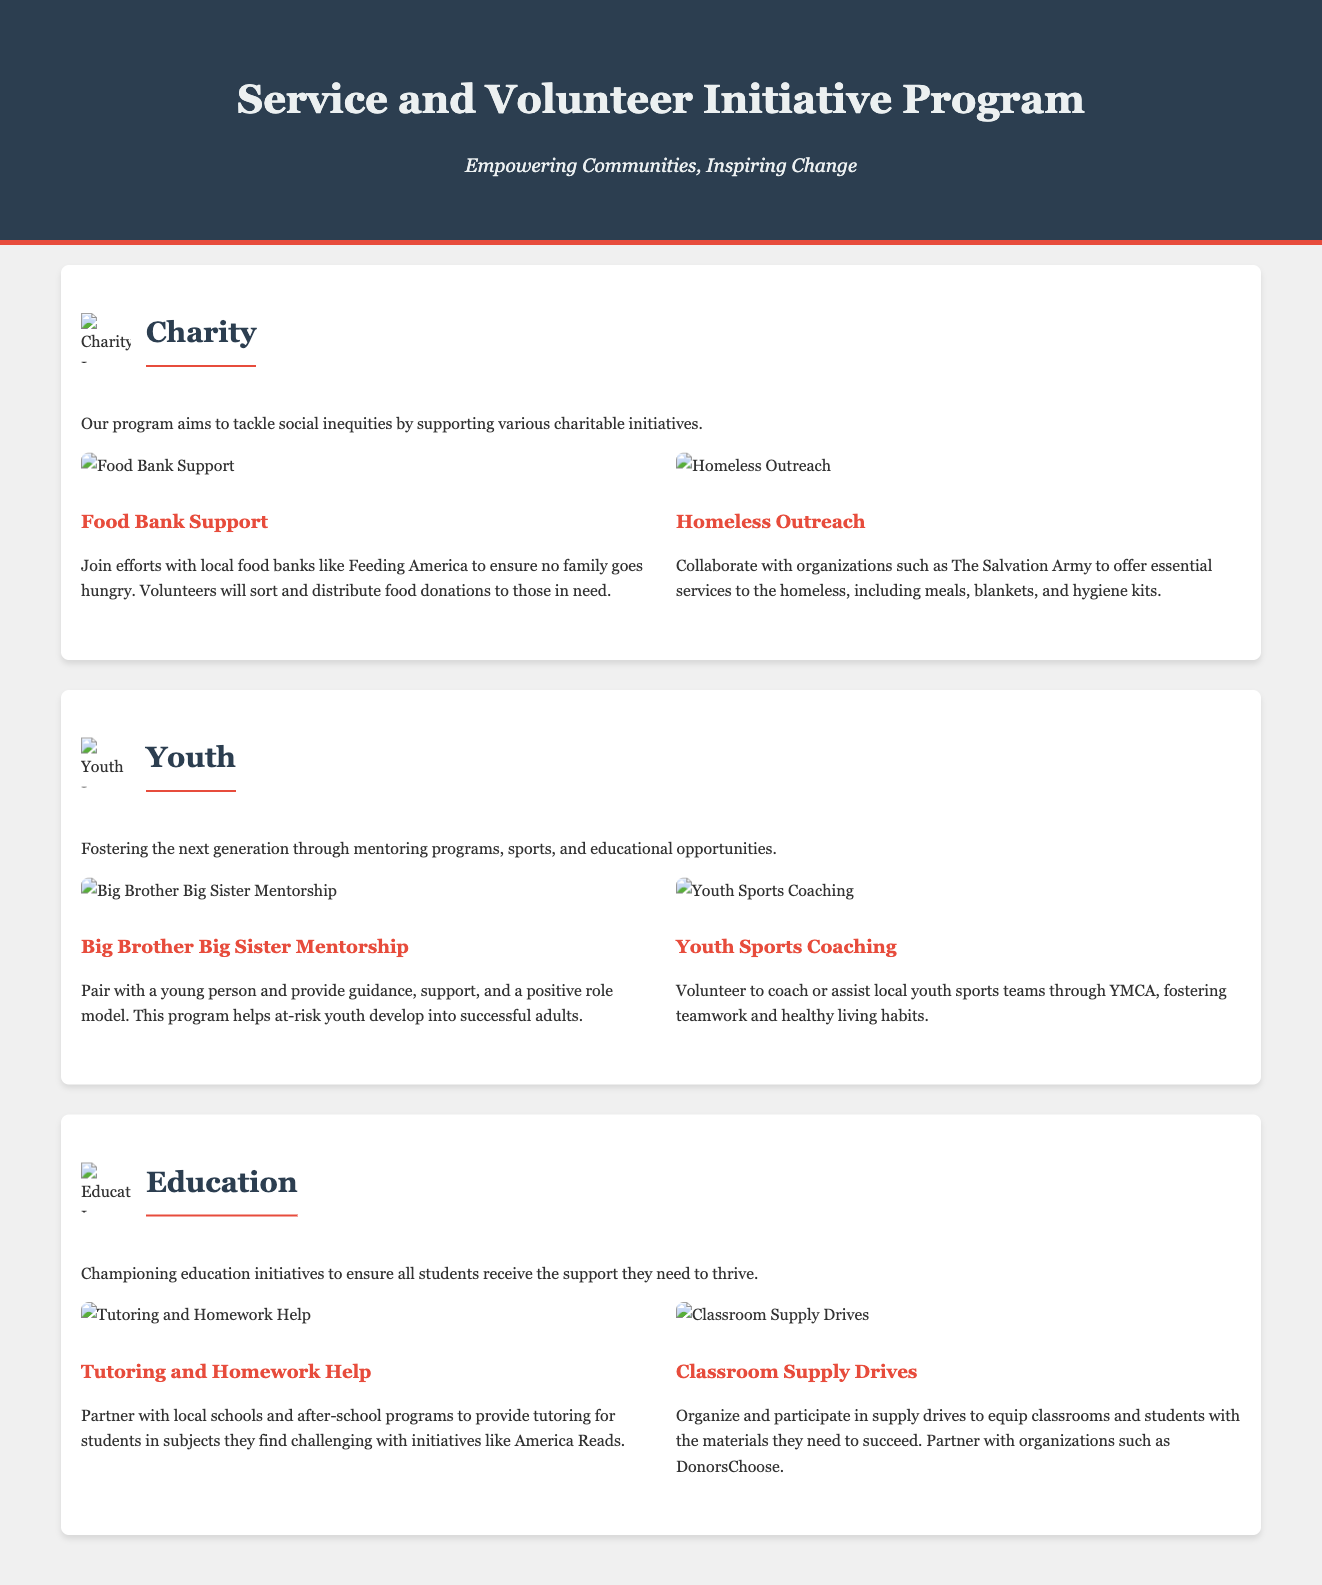What is the title of the program? The title of the program is prominently displayed in the header of the document.
Answer: Service and Volunteer Initiative Program What theme is associated with the icon that includes a food bank? The food bank icon corresponds to a specific theme highlighted in the document.
Answer: Charity How many volunteering opportunities are listed under the Youth section? The document provides details of two specific opportunities under the Youth theme.
Answer: 2 What organization partners with the program for tutoring initiatives? The tutoring opportunity mentions a specific national initiative related to education.
Answer: America Reads What kind of support does the program provide to the homeless? The document outlines specific services offered to the homeless through collaboration with an organization.
Answer: Meals, blankets, and hygiene kits Which initiative is designed to help at-risk youth? The mentoring program details a specific initiative aimed at supporting vulnerable youth.
Answer: Big Brother Big Sister Mentorship What type of drives are mentioned under the Education section? The document describes a specific type of collection effort related to educational materials.
Answer: Classroom Supply Drives 